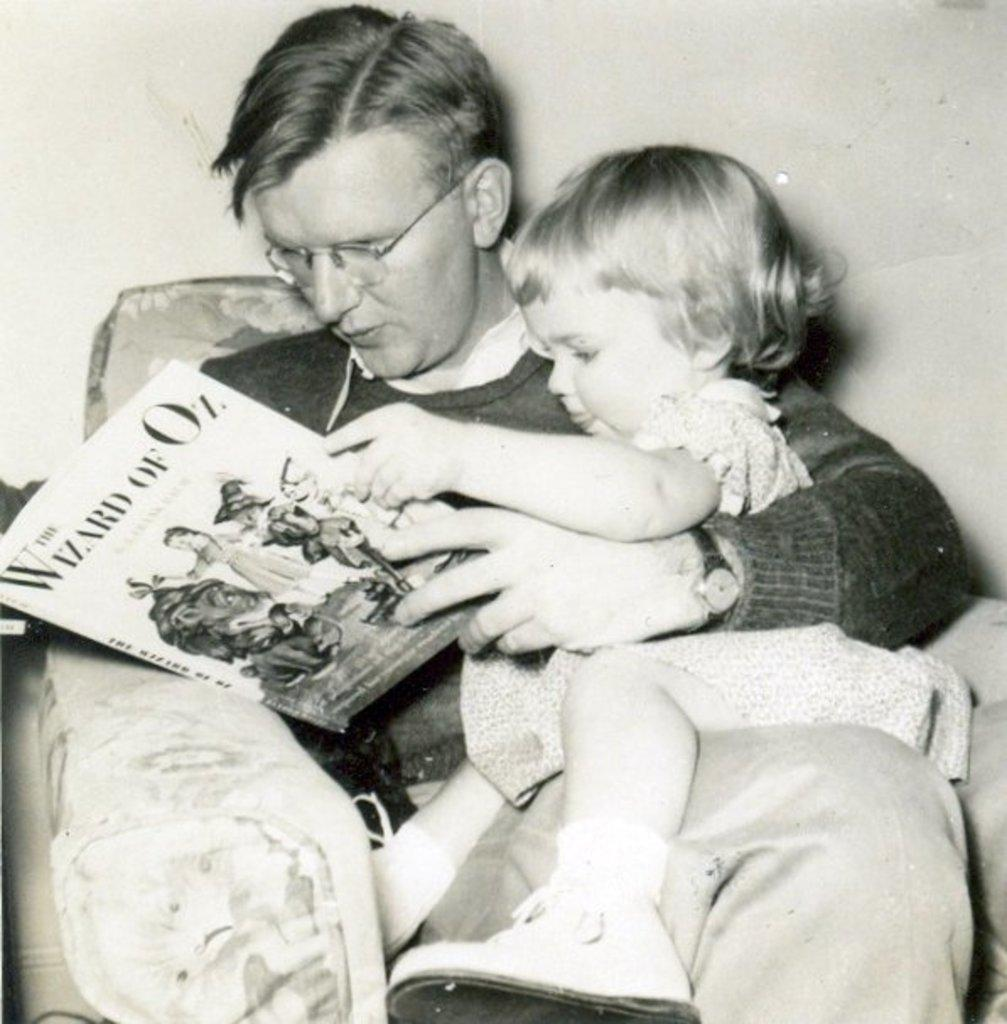What is the man in the image doing? The man is sitting on a sofa in the image. What is the man holding in the image? The man is holding a book. Is there anyone else in the image? Yes, there is a girl sitting on the man. What can be seen in the background of the image? There is a wall in the background of the image. What type of drain can be seen in the image? There is no drain present in the image. Is there a hall visible in the image? The image does not show a hall; it only shows a man sitting on a sofa with a girl and a wall in the background. 